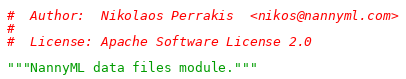Convert code to text. <code><loc_0><loc_0><loc_500><loc_500><_Python_>#  Author:  Nikolaos Perrakis  <nikos@nannyml.com>
#
#  License: Apache Software License 2.0

"""NannyML data files module."""
</code> 